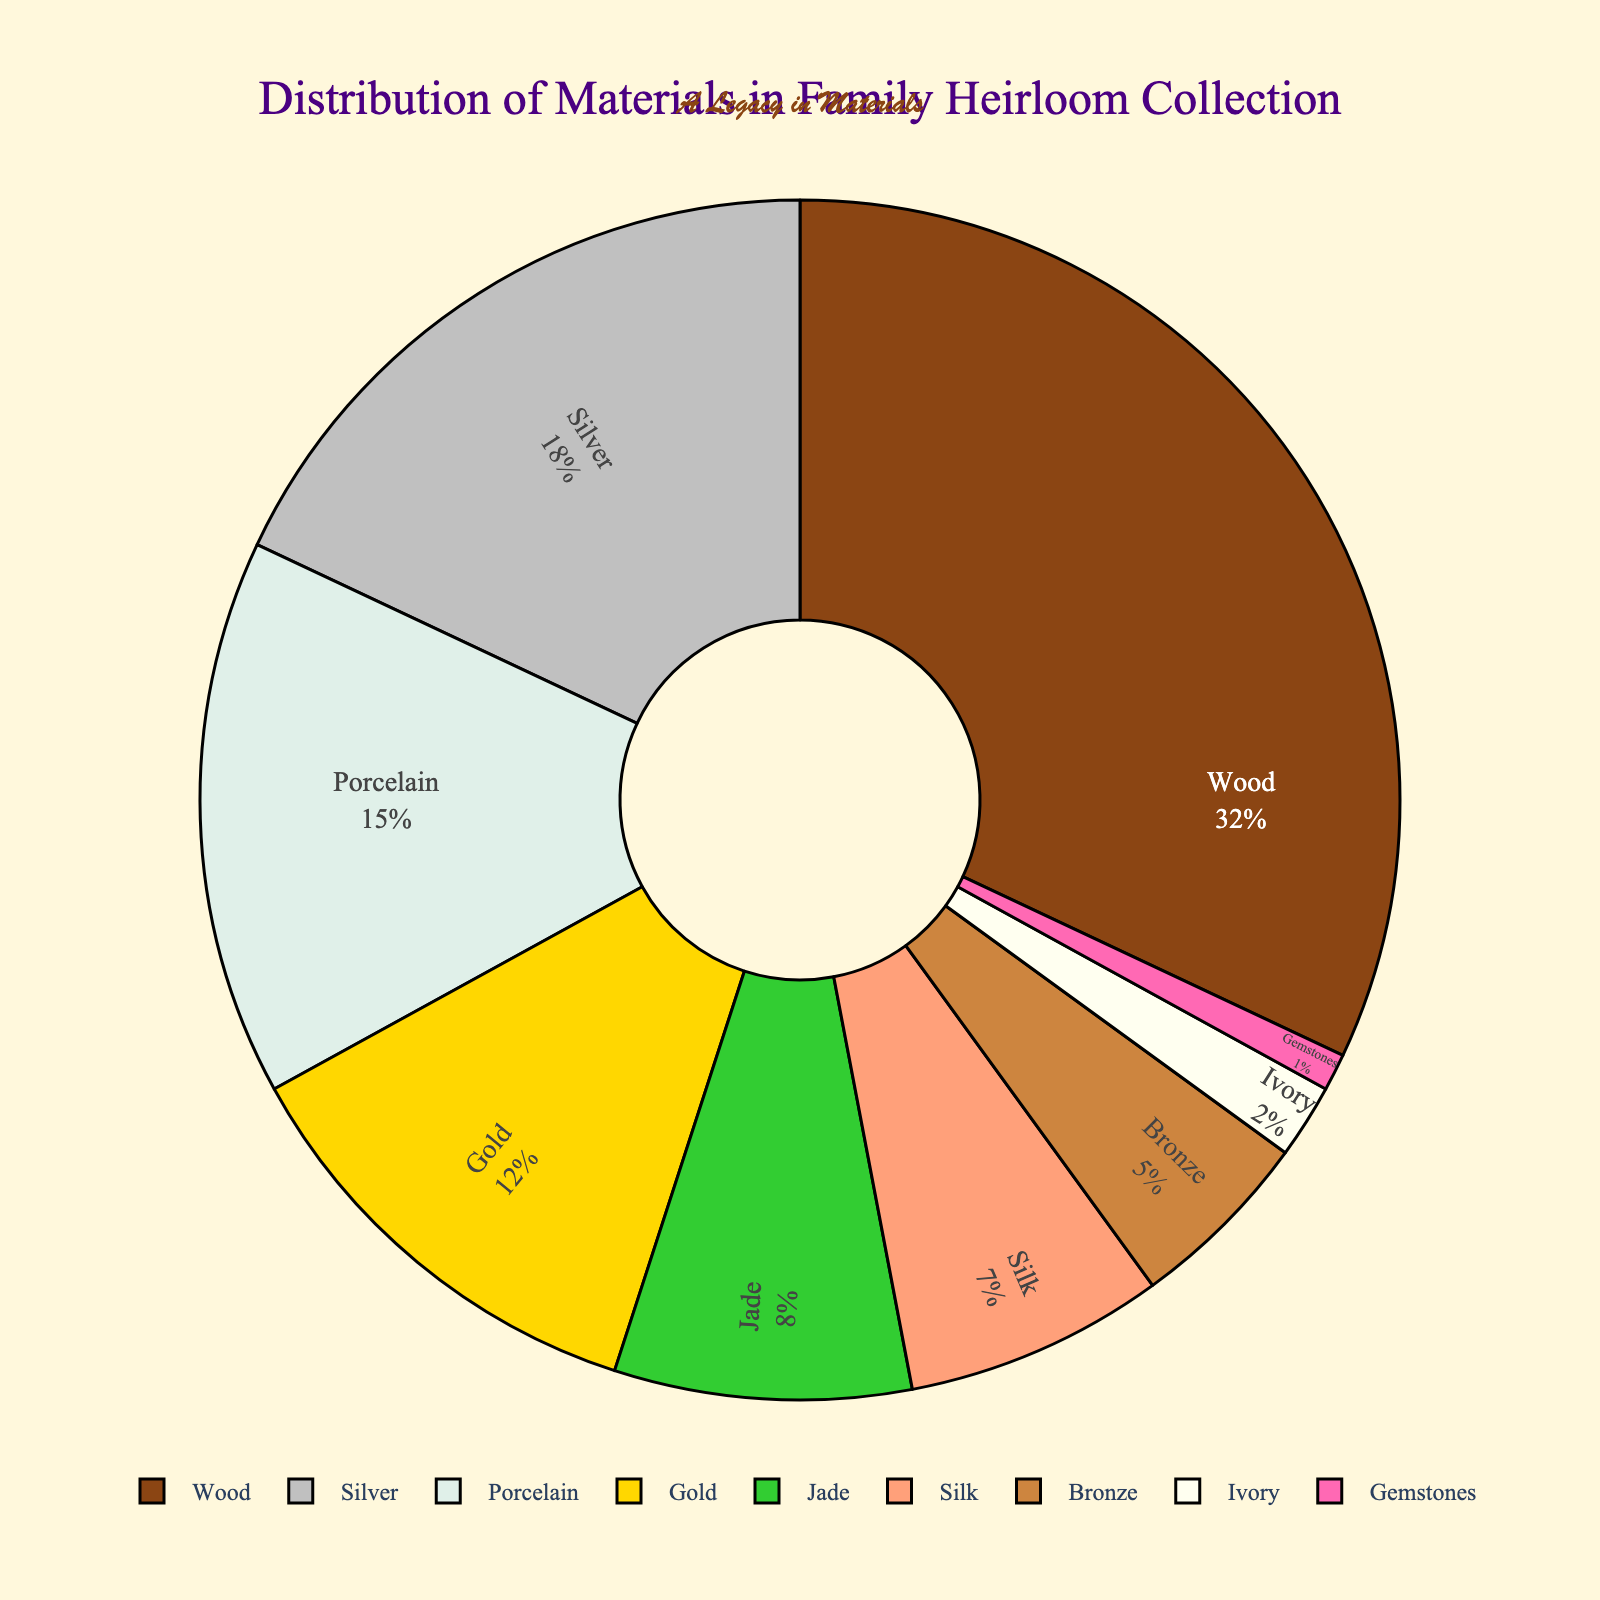Which material is used most frequently? The material with the highest percentage in the pie chart is the most frequently used. In this case, Wood has the highest percentage at 32%.
Answer: Wood Which material is used less frequently, Bronze or Silk? Compare the percentages of Bronze and Silk in the pie chart. Bronze has a percentage of 5%, and Silk has a percentage of 7%. Since 5% (Bronze) is less than 7% (Silk), Bronze is used less frequently.
Answer: Bronze What is the combined percentage of Silver and Gold? To find the combined percentage, add the percentage of Silver and Gold. Silver is 18% and Gold is 12%, so 18% + 12% = 30%.
Answer: 30% How much more frequently is Wood used compared to Jade? Subtract the percentage of Jade from the percentage of Wood. Wood is 32% and Jade is 8%, so 32% - 8% = 24%.
Answer: 24% Which materials each constitute less than 10% of the collection? Identify all materials with a percentage less than 10% from the pie chart. Jade (8%), Silk (7%), Bronze (5%), Ivory (2%), and Gemstones (1%) all fall below 10%.
Answer: Jade, Silk, Bronze, Ivory, Gemstones Are there more items made of Silver or Gold and by how much? Compare the percentages of Silver and Gold. Silver is 18%, and Gold is 12%. Subtract Gold from Silver to find the difference in percentage: 18% - 12% = 6%.
Answer: Silver by 6% If items made of Wood and Porcelain were combined into one category, what would its new percentage be? Add the percentages of Wood and Porcelain. Wood is 32% and Porcelain is 15%, so 32% + 15% = 47%.
Answer: 47% How does the visual size of the section for Wood compare to the visual size of the section for Ivory? Wood has a much larger percentage (32%) compared to Ivory (2%), which means the section for Wood will be significantly larger than the section for Ivory on the pie chart.
Answer: Wood is much larger Which material's section in the pie chart is depicted with a golden color? By interpreting the color scheme in the pie chart, the section depicted with a golden color corresponds to the material Gold.
Answer: Gold If we grouped all materials with a percentage less than 5% together, what would be the total percentage? Summing the percentages of Bronze (5%), Ivory (2%), and Gemstones (1%) gives: 5% + 2% + 1% = 8%. However, this includes Bronze which is exactly 5%, not less. Therefore, Ivory and Gemstones combined: 2% + 1% = 3%.
Answer: 3% 